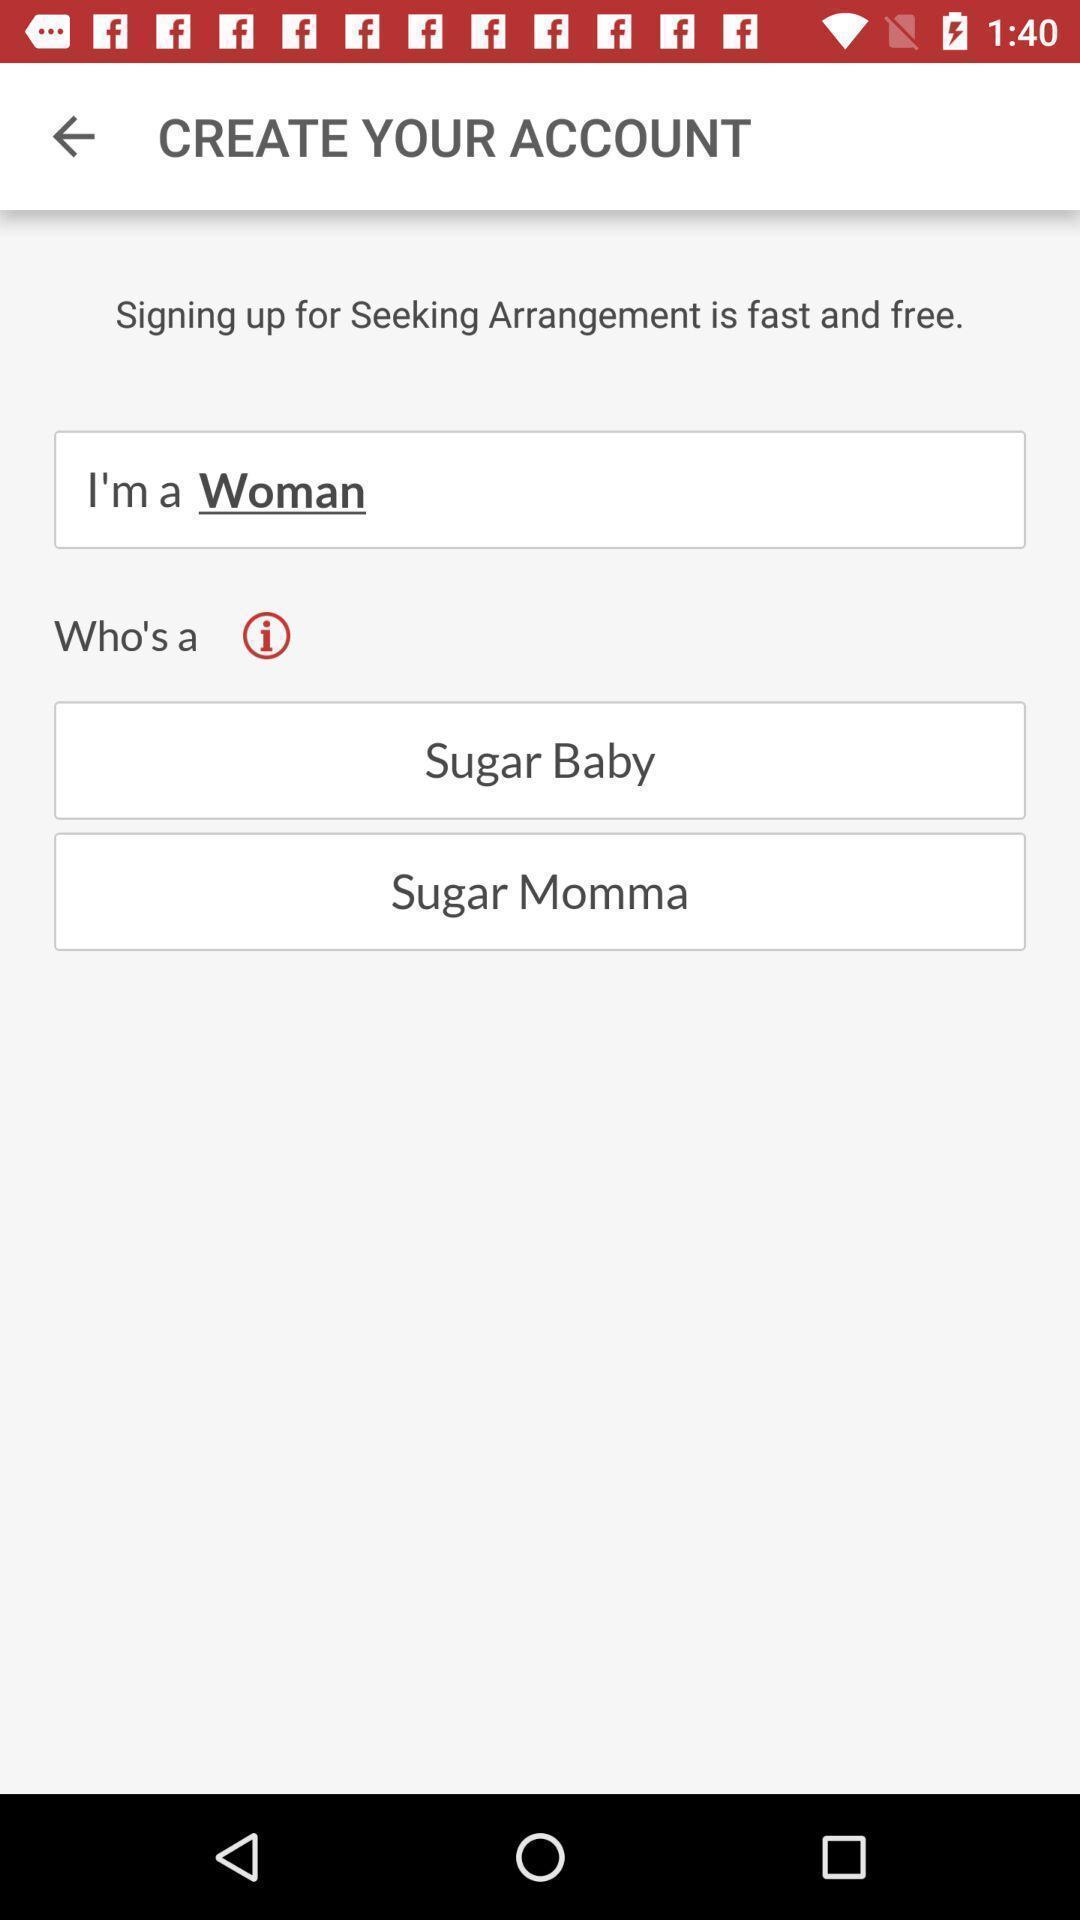Summarize the information in this screenshot. Window displaying a dating app. 